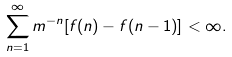Convert formula to latex. <formula><loc_0><loc_0><loc_500><loc_500>\sum _ { n = 1 } ^ { \infty } m ^ { - n } [ f ( n ) - f ( n - 1 ) ] < \infty .</formula> 